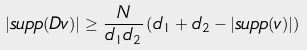Convert formula to latex. <formula><loc_0><loc_0><loc_500><loc_500>| s u p p ( D v ) | \geq \frac { N } { d _ { 1 } d _ { 2 } } \left ( d _ { 1 } + d _ { 2 } - | s u p p ( v ) | \right )</formula> 